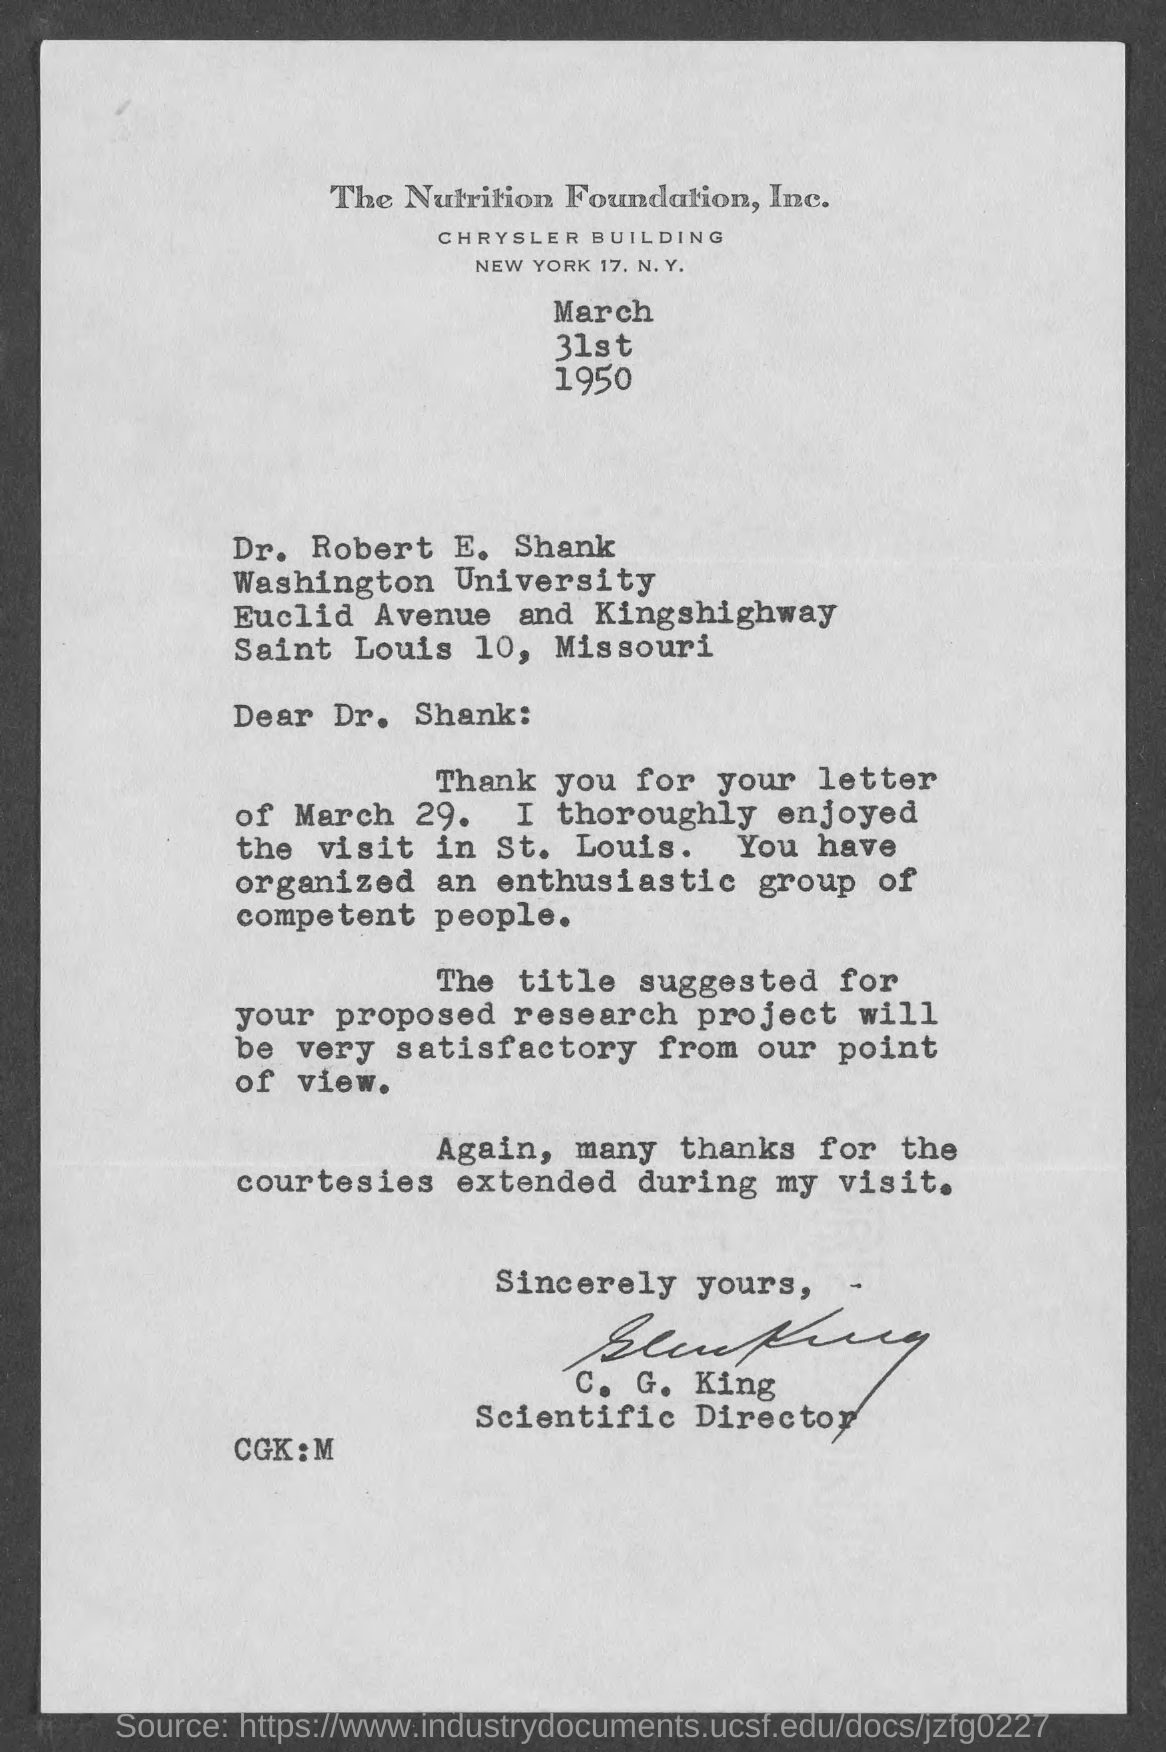What is the date mentioned in the given letter ?
Provide a short and direct response. March 31st 1950. To which university dr. robert e. shank belongs to ?
Offer a terse response. Washington university. What is the designation of c.g.king ?
Ensure brevity in your answer.  SCIENTIFIC DIRECTOR. 